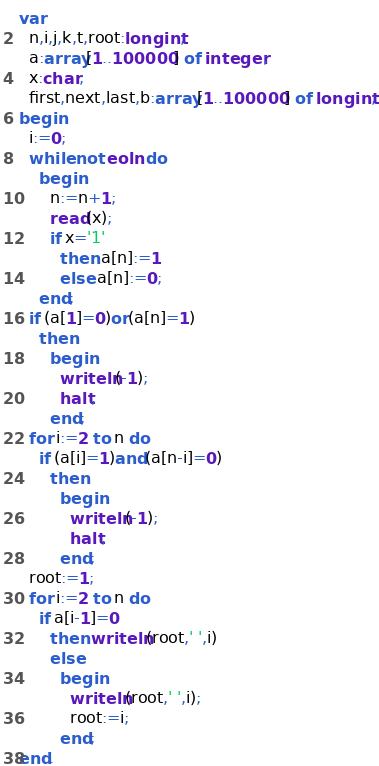<code> <loc_0><loc_0><loc_500><loc_500><_Pascal_>var
  n,i,j,k,t,root:longint;
  a:array[1..100000] of integer;
  x:char;
  first,next,last,b:array[1..100000] of longint;
begin
  i:=0;
  while not eoln do
    begin
      n:=n+1;
      read(x);
      if x='1'
        then a[n]:=1
        else a[n]:=0;
    end;
  if (a[1]=0)or(a[n]=1)
    then
      begin
        writeln(-1);
        halt;
      end;
  for i:=2 to n do
    if (a[i]=1)and(a[n-i]=0)
      then
        begin
          writeln(-1);
          halt;
        end;
  root:=1;
  for i:=2 to n do
    if a[i-1]=0
      then writeln(root,' ',i)
      else
        begin
          writeln(root,' ',i);
          root:=i;
        end;
end.
</code> 